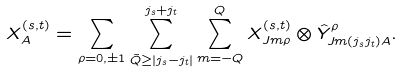<formula> <loc_0><loc_0><loc_500><loc_500>X _ { A } ^ { ( s , t ) } = \sum _ { \rho = 0 , \pm 1 } \sum _ { \tilde { Q } \geq | j _ { s } - j _ { t } | } ^ { j _ { s } + j _ { t } } \sum _ { m = - Q } ^ { Q } X _ { J m \rho } ^ { ( s , t ) } \otimes \hat { Y } _ { J m ( j _ { s } j _ { t } ) A } ^ { \rho } .</formula> 